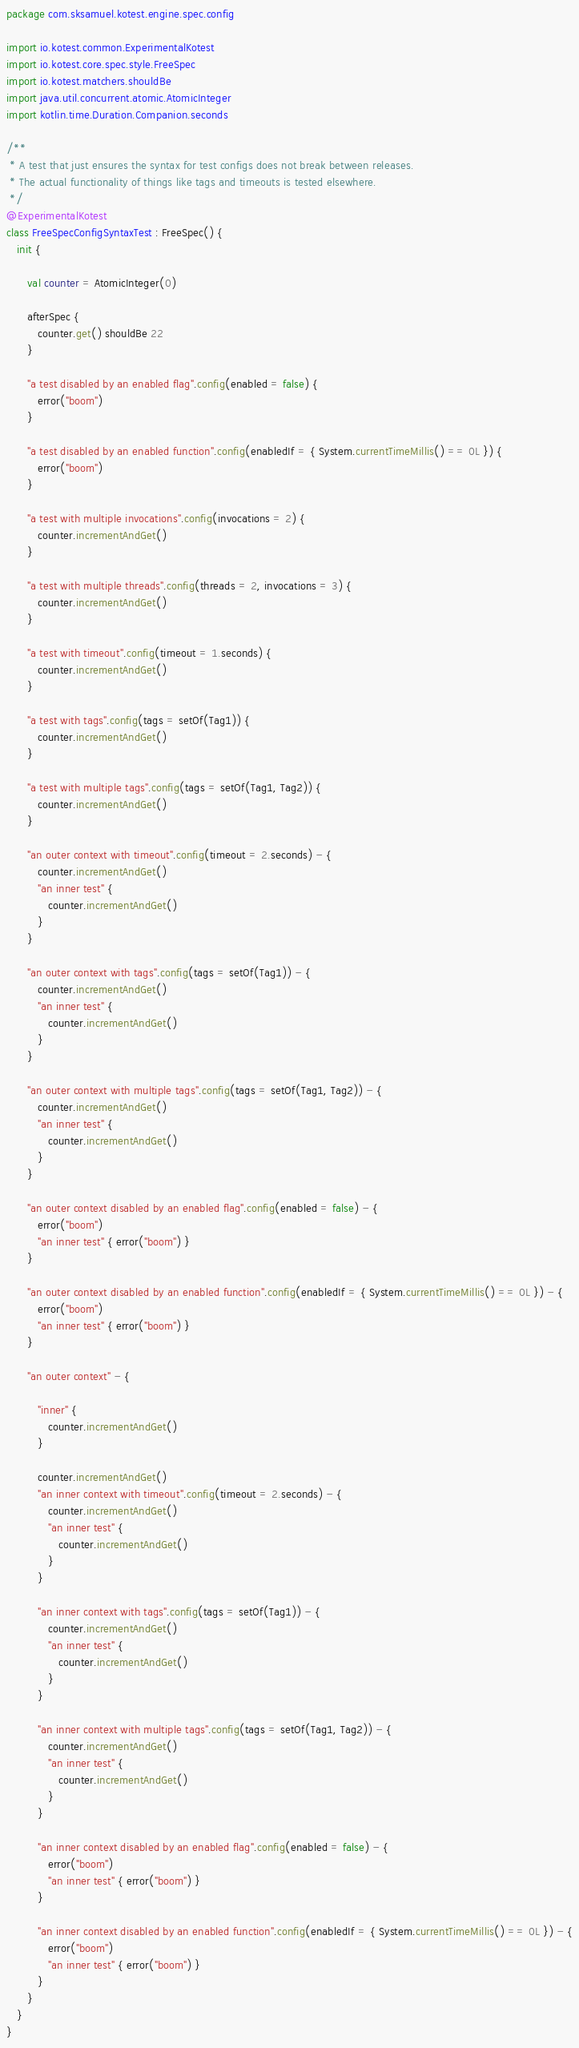<code> <loc_0><loc_0><loc_500><loc_500><_Kotlin_>package com.sksamuel.kotest.engine.spec.config

import io.kotest.common.ExperimentalKotest
import io.kotest.core.spec.style.FreeSpec
import io.kotest.matchers.shouldBe
import java.util.concurrent.atomic.AtomicInteger
import kotlin.time.Duration.Companion.seconds

/**
 * A test that just ensures the syntax for test configs does not break between releases.
 * The actual functionality of things like tags and timeouts is tested elsewhere.
 */
@ExperimentalKotest
class FreeSpecConfigSyntaxTest : FreeSpec() {
   init {

      val counter = AtomicInteger(0)

      afterSpec {
         counter.get() shouldBe 22
      }

      "a test disabled by an enabled flag".config(enabled = false) {
         error("boom")
      }

      "a test disabled by an enabled function".config(enabledIf = { System.currentTimeMillis() == 0L }) {
         error("boom")
      }

      "a test with multiple invocations".config(invocations = 2) {
         counter.incrementAndGet()
      }

      "a test with multiple threads".config(threads = 2, invocations = 3) {
         counter.incrementAndGet()
      }

      "a test with timeout".config(timeout = 1.seconds) {
         counter.incrementAndGet()
      }

      "a test with tags".config(tags = setOf(Tag1)) {
         counter.incrementAndGet()
      }

      "a test with multiple tags".config(tags = setOf(Tag1, Tag2)) {
         counter.incrementAndGet()
      }

      "an outer context with timeout".config(timeout = 2.seconds) - {
         counter.incrementAndGet()
         "an inner test" {
            counter.incrementAndGet()
         }
      }

      "an outer context with tags".config(tags = setOf(Tag1)) - {
         counter.incrementAndGet()
         "an inner test" {
            counter.incrementAndGet()
         }
      }

      "an outer context with multiple tags".config(tags = setOf(Tag1, Tag2)) - {
         counter.incrementAndGet()
         "an inner test" {
            counter.incrementAndGet()
         }
      }

      "an outer context disabled by an enabled flag".config(enabled = false) - {
         error("boom")
         "an inner test" { error("boom") }
      }

      "an outer context disabled by an enabled function".config(enabledIf = { System.currentTimeMillis() == 0L }) - {
         error("boom")
         "an inner test" { error("boom") }
      }

      "an outer context" - {

         "inner" {
            counter.incrementAndGet()
         }

         counter.incrementAndGet()
         "an inner context with timeout".config(timeout = 2.seconds) - {
            counter.incrementAndGet()
            "an inner test" {
               counter.incrementAndGet()
            }
         }

         "an inner context with tags".config(tags = setOf(Tag1)) - {
            counter.incrementAndGet()
            "an inner test" {
               counter.incrementAndGet()
            }
         }

         "an inner context with multiple tags".config(tags = setOf(Tag1, Tag2)) - {
            counter.incrementAndGet()
            "an inner test" {
               counter.incrementAndGet()
            }
         }

         "an inner context disabled by an enabled flag".config(enabled = false) - {
            error("boom")
            "an inner test" { error("boom") }
         }

         "an inner context disabled by an enabled function".config(enabledIf = { System.currentTimeMillis() == 0L }) - {
            error("boom")
            "an inner test" { error("boom") }
         }
      }
   }
}
</code> 